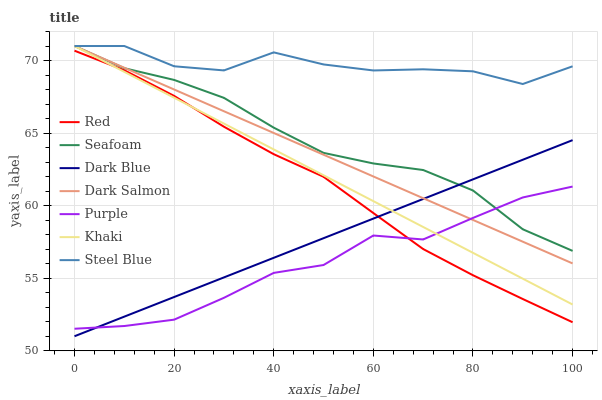Does Purple have the minimum area under the curve?
Answer yes or no. Yes. Does Steel Blue have the maximum area under the curve?
Answer yes or no. Yes. Does Seafoam have the minimum area under the curve?
Answer yes or no. No. Does Seafoam have the maximum area under the curve?
Answer yes or no. No. Is Dark Blue the smoothest?
Answer yes or no. Yes. Is Steel Blue the roughest?
Answer yes or no. Yes. Is Purple the smoothest?
Answer yes or no. No. Is Purple the roughest?
Answer yes or no. No. Does Dark Blue have the lowest value?
Answer yes or no. Yes. Does Purple have the lowest value?
Answer yes or no. No. Does Steel Blue have the highest value?
Answer yes or no. Yes. Does Purple have the highest value?
Answer yes or no. No. Is Red less than Steel Blue?
Answer yes or no. Yes. Is Steel Blue greater than Purple?
Answer yes or no. Yes. Does Seafoam intersect Steel Blue?
Answer yes or no. Yes. Is Seafoam less than Steel Blue?
Answer yes or no. No. Is Seafoam greater than Steel Blue?
Answer yes or no. No. Does Red intersect Steel Blue?
Answer yes or no. No. 